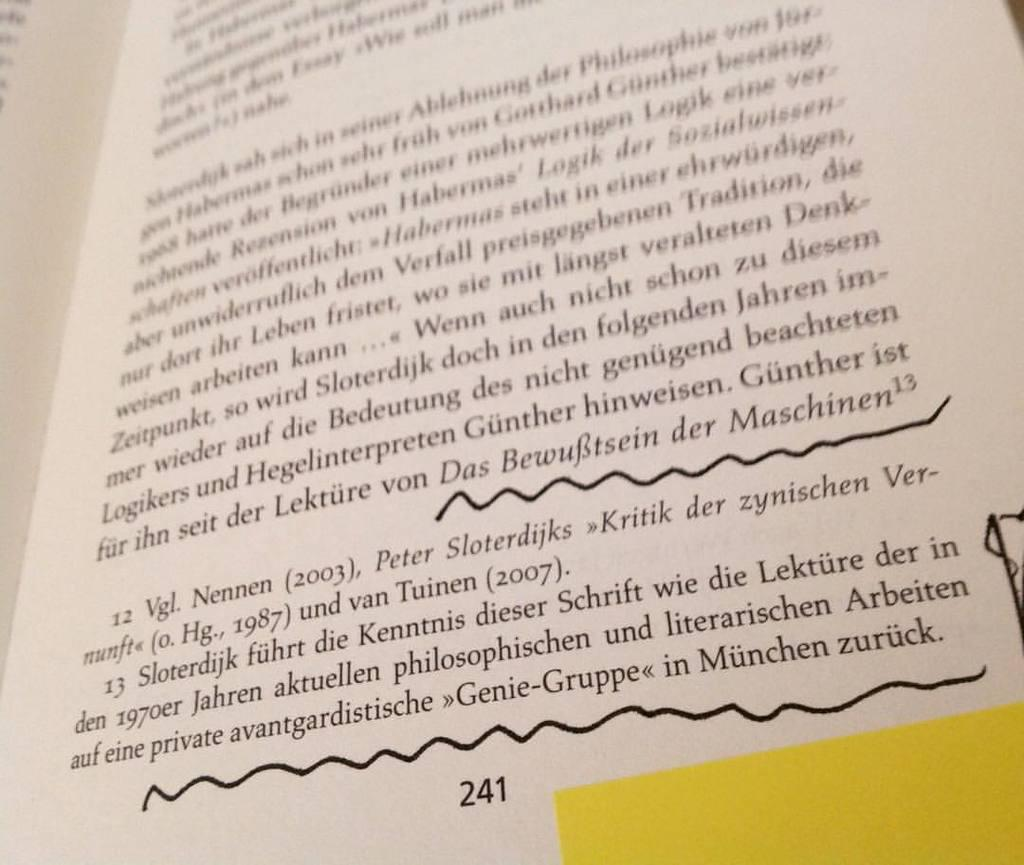<image>
Provide a brief description of the given image. Chapter book that is on page 241 about Peter Sloterdijks and Vgl Nenmen. 